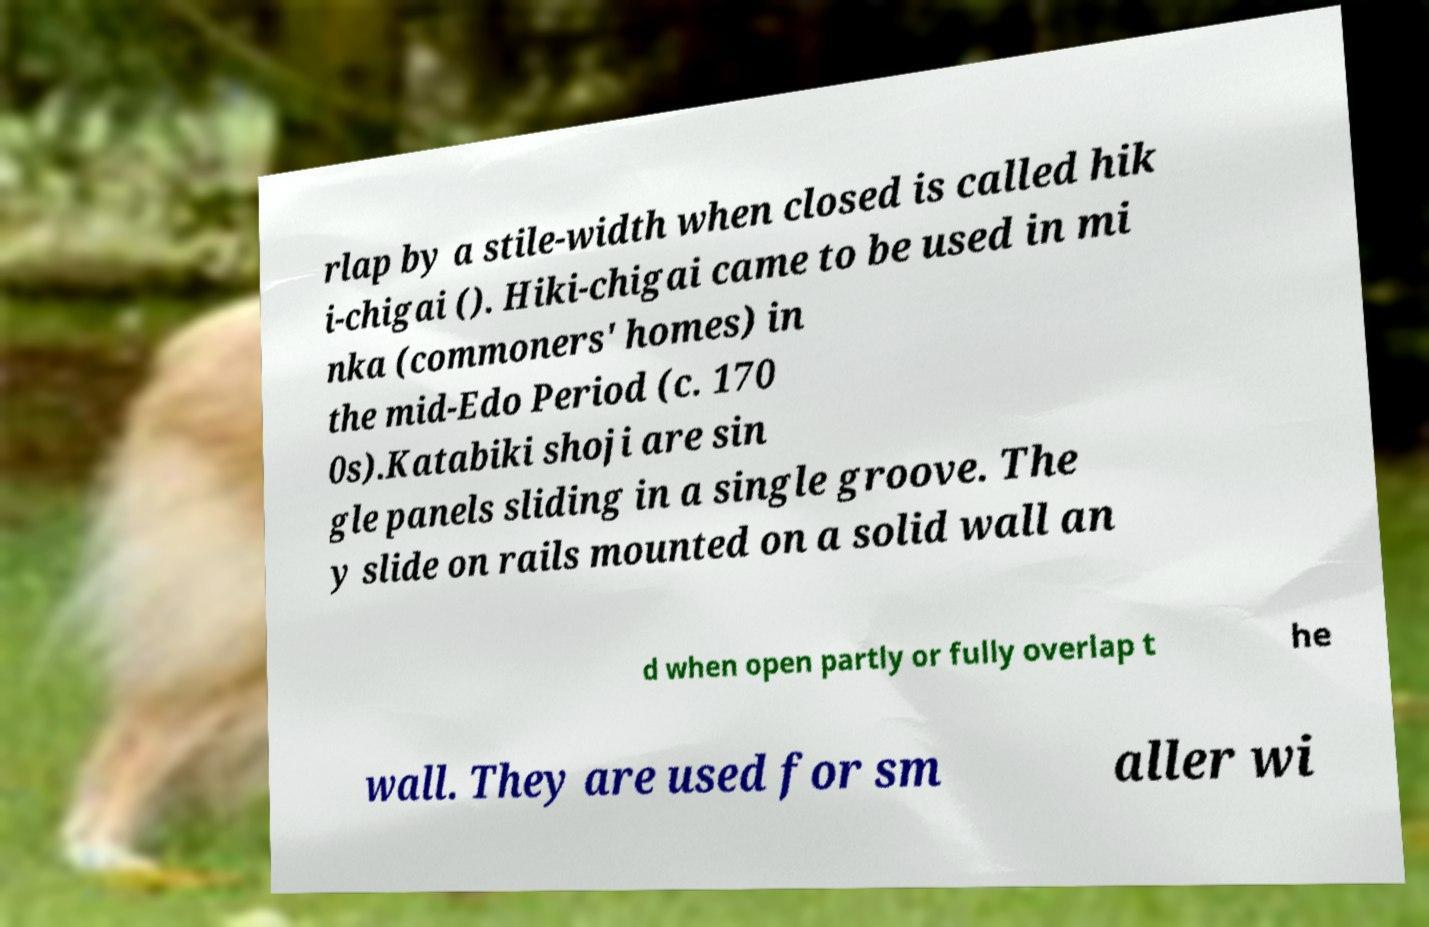Can you accurately transcribe the text from the provided image for me? rlap by a stile-width when closed is called hik i-chigai (). Hiki-chigai came to be used in mi nka (commoners' homes) in the mid-Edo Period (c. 170 0s).Katabiki shoji are sin gle panels sliding in a single groove. The y slide on rails mounted on a solid wall an d when open partly or fully overlap t he wall. They are used for sm aller wi 